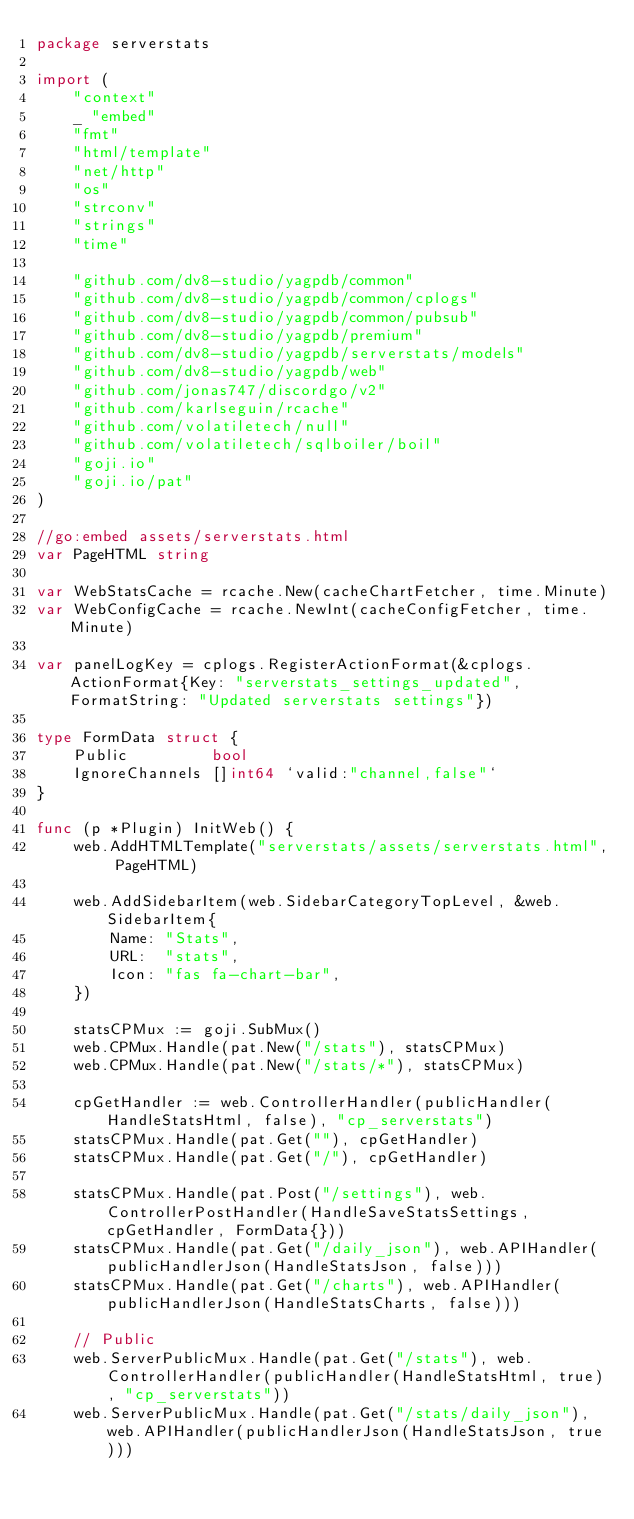<code> <loc_0><loc_0><loc_500><loc_500><_Go_>package serverstats

import (
	"context"
	_ "embed"
	"fmt"
	"html/template"
	"net/http"
	"os"
	"strconv"
	"strings"
	"time"

	"github.com/dv8-studio/yagpdb/common"
	"github.com/dv8-studio/yagpdb/common/cplogs"
	"github.com/dv8-studio/yagpdb/common/pubsub"
	"github.com/dv8-studio/yagpdb/premium"
	"github.com/dv8-studio/yagpdb/serverstats/models"
	"github.com/dv8-studio/yagpdb/web"
	"github.com/jonas747/discordgo/v2"
	"github.com/karlseguin/rcache"
	"github.com/volatiletech/null"
	"github.com/volatiletech/sqlboiler/boil"
	"goji.io"
	"goji.io/pat"
)

//go:embed assets/serverstats.html
var PageHTML string

var WebStatsCache = rcache.New(cacheChartFetcher, time.Minute)
var WebConfigCache = rcache.NewInt(cacheConfigFetcher, time.Minute)

var panelLogKey = cplogs.RegisterActionFormat(&cplogs.ActionFormat{Key: "serverstats_settings_updated", FormatString: "Updated serverstats settings"})

type FormData struct {
	Public         bool
	IgnoreChannels []int64 `valid:"channel,false"`
}

func (p *Plugin) InitWeb() {
	web.AddHTMLTemplate("serverstats/assets/serverstats.html", PageHTML)

	web.AddSidebarItem(web.SidebarCategoryTopLevel, &web.SidebarItem{
		Name: "Stats",
		URL:  "stats",
		Icon: "fas fa-chart-bar",
	})

	statsCPMux := goji.SubMux()
	web.CPMux.Handle(pat.New("/stats"), statsCPMux)
	web.CPMux.Handle(pat.New("/stats/*"), statsCPMux)

	cpGetHandler := web.ControllerHandler(publicHandler(HandleStatsHtml, false), "cp_serverstats")
	statsCPMux.Handle(pat.Get(""), cpGetHandler)
	statsCPMux.Handle(pat.Get("/"), cpGetHandler)

	statsCPMux.Handle(pat.Post("/settings"), web.ControllerPostHandler(HandleSaveStatsSettings, cpGetHandler, FormData{}))
	statsCPMux.Handle(pat.Get("/daily_json"), web.APIHandler(publicHandlerJson(HandleStatsJson, false)))
	statsCPMux.Handle(pat.Get("/charts"), web.APIHandler(publicHandlerJson(HandleStatsCharts, false)))

	// Public
	web.ServerPublicMux.Handle(pat.Get("/stats"), web.ControllerHandler(publicHandler(HandleStatsHtml, true), "cp_serverstats"))
	web.ServerPublicMux.Handle(pat.Get("/stats/daily_json"), web.APIHandler(publicHandlerJson(HandleStatsJson, true)))</code> 